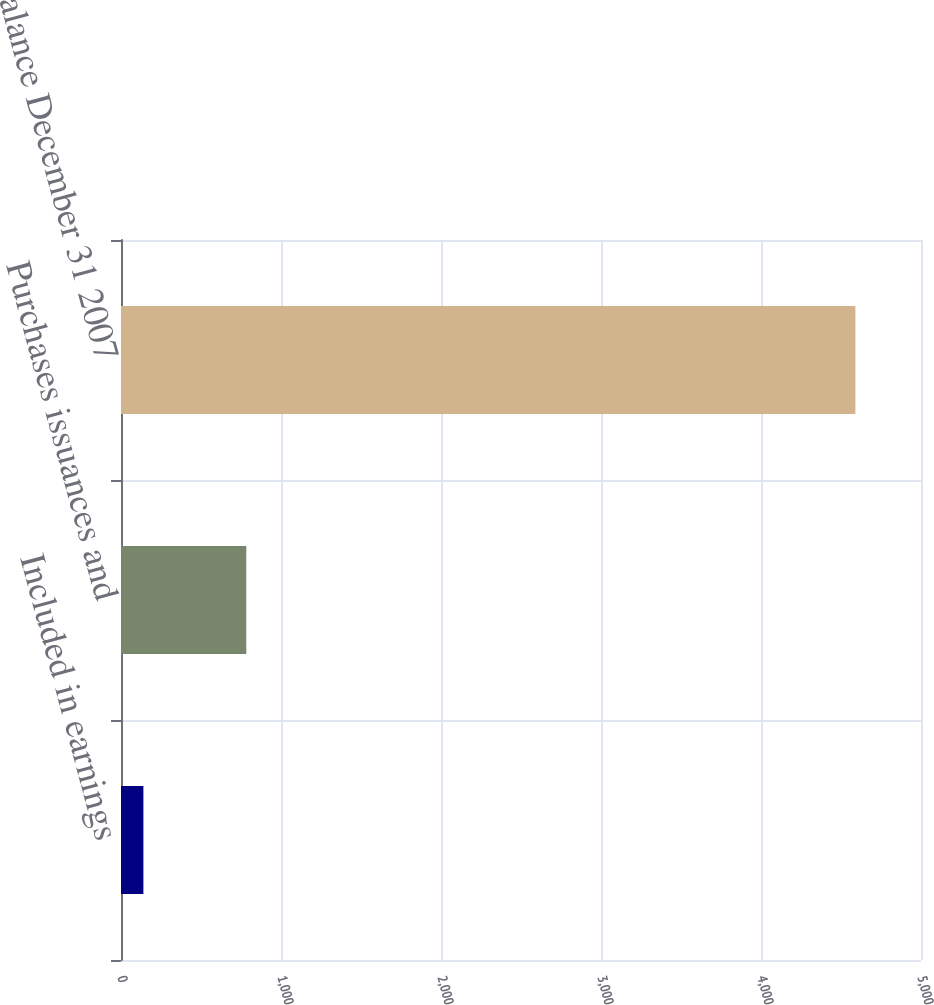Convert chart to OTSL. <chart><loc_0><loc_0><loc_500><loc_500><bar_chart><fcel>Included in earnings<fcel>Purchases issuances and<fcel>Balance December 31 2007<nl><fcel>140<fcel>783<fcel>4590<nl></chart> 